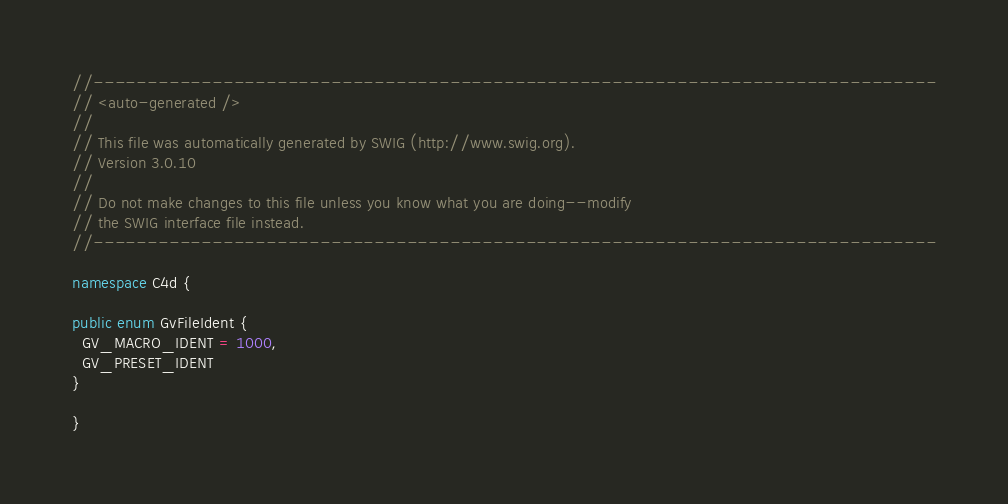<code> <loc_0><loc_0><loc_500><loc_500><_C#_>//------------------------------------------------------------------------------
// <auto-generated />
//
// This file was automatically generated by SWIG (http://www.swig.org).
// Version 3.0.10
//
// Do not make changes to this file unless you know what you are doing--modify
// the SWIG interface file instead.
//------------------------------------------------------------------------------

namespace C4d {

public enum GvFileIdent {
  GV_MACRO_IDENT = 1000,
  GV_PRESET_IDENT
}

}
</code> 